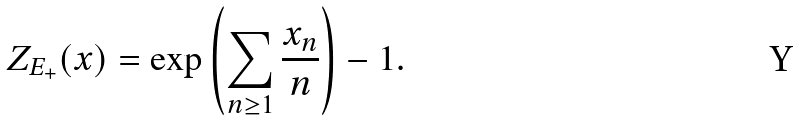<formula> <loc_0><loc_0><loc_500><loc_500>Z _ { E _ { + } } ( x ) = \exp \left ( \sum _ { n \geq 1 } \frac { x _ { n } } { n } \right ) - 1 .</formula> 